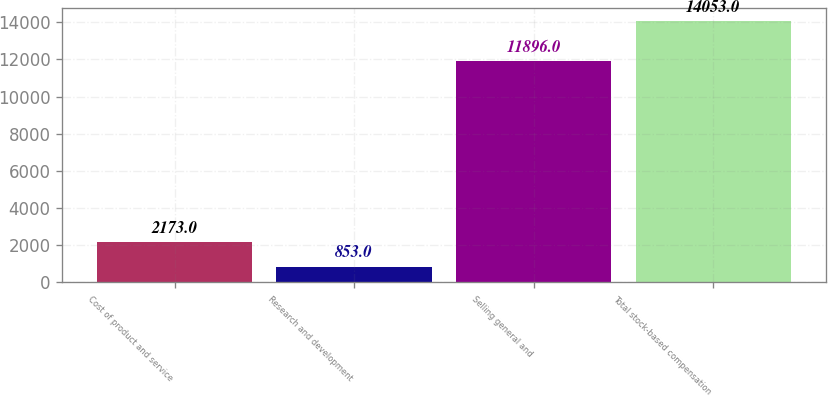Convert chart. <chart><loc_0><loc_0><loc_500><loc_500><bar_chart><fcel>Cost of product and service<fcel>Research and development<fcel>Selling general and<fcel>Total stock-based compensation<nl><fcel>2173<fcel>853<fcel>11896<fcel>14053<nl></chart> 